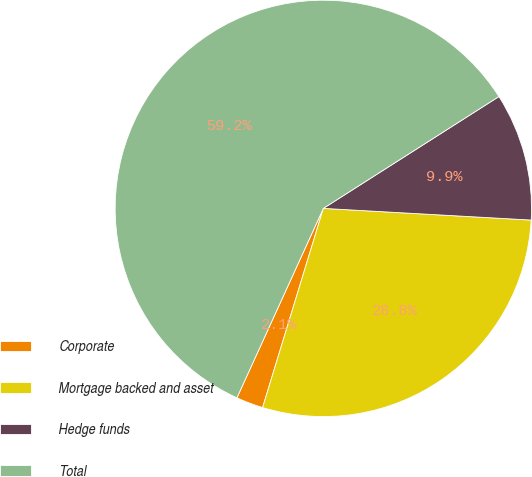<chart> <loc_0><loc_0><loc_500><loc_500><pie_chart><fcel>Corporate<fcel>Mortgage backed and asset<fcel>Hedge funds<fcel>Total<nl><fcel>2.1%<fcel>28.82%<fcel>9.92%<fcel>59.16%<nl></chart> 